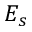<formula> <loc_0><loc_0><loc_500><loc_500>E _ { s }</formula> 